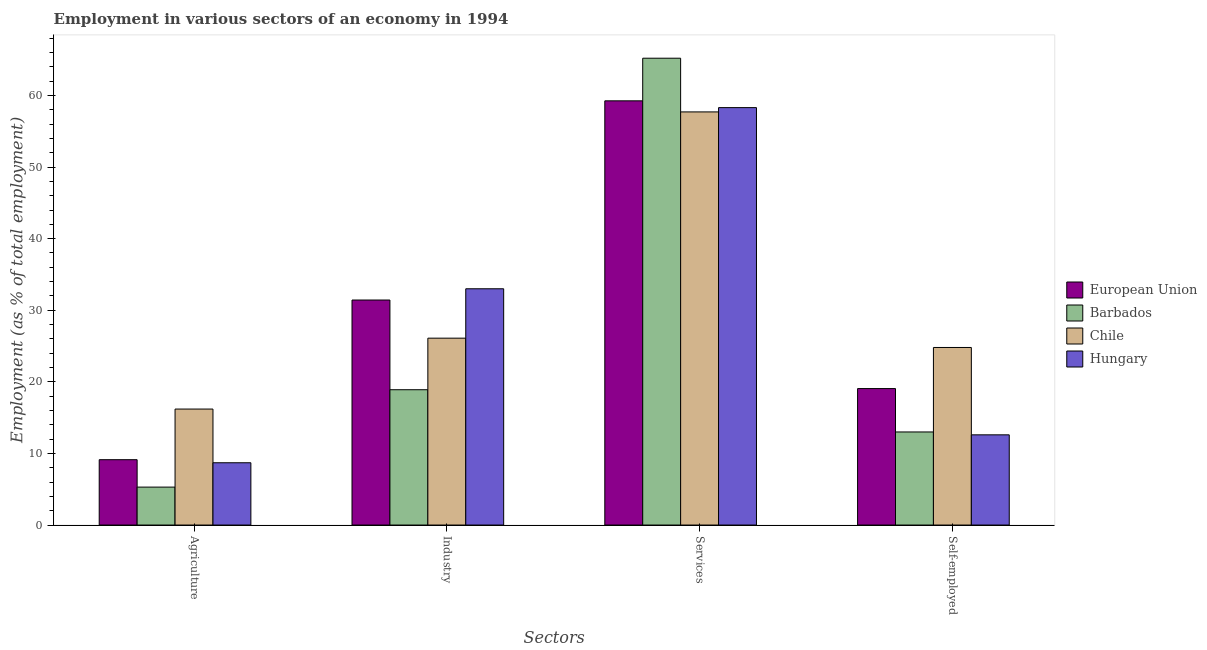How many different coloured bars are there?
Give a very brief answer. 4. How many bars are there on the 2nd tick from the left?
Keep it short and to the point. 4. How many bars are there on the 1st tick from the right?
Give a very brief answer. 4. What is the label of the 4th group of bars from the left?
Give a very brief answer. Self-employed. What is the percentage of workers in industry in Barbados?
Provide a short and direct response. 18.9. Across all countries, what is the maximum percentage of workers in industry?
Your answer should be compact. 33. Across all countries, what is the minimum percentage of workers in agriculture?
Provide a succinct answer. 5.3. In which country was the percentage of workers in agriculture maximum?
Your response must be concise. Chile. In which country was the percentage of workers in agriculture minimum?
Keep it short and to the point. Barbados. What is the total percentage of self employed workers in the graph?
Keep it short and to the point. 69.46. What is the difference between the percentage of self employed workers in Hungary and that in Chile?
Offer a very short reply. -12.2. What is the difference between the percentage of self employed workers in European Union and the percentage of workers in agriculture in Barbados?
Give a very brief answer. 13.76. What is the average percentage of workers in services per country?
Your response must be concise. 60.11. What is the difference between the percentage of workers in industry and percentage of workers in services in Hungary?
Your answer should be very brief. -25.3. In how many countries, is the percentage of workers in industry greater than 50 %?
Your answer should be very brief. 0. What is the ratio of the percentage of self employed workers in Hungary to that in Barbados?
Keep it short and to the point. 0.97. What is the difference between the highest and the second highest percentage of self employed workers?
Your response must be concise. 5.74. What is the difference between the highest and the lowest percentage of workers in agriculture?
Your answer should be compact. 10.9. Is it the case that in every country, the sum of the percentage of workers in agriculture and percentage of workers in services is greater than the sum of percentage of workers in industry and percentage of self employed workers?
Your answer should be very brief. No. What does the 2nd bar from the left in Agriculture represents?
Your answer should be compact. Barbados. Is it the case that in every country, the sum of the percentage of workers in agriculture and percentage of workers in industry is greater than the percentage of workers in services?
Keep it short and to the point. No. Does the graph contain grids?
Offer a very short reply. No. Where does the legend appear in the graph?
Ensure brevity in your answer.  Center right. How many legend labels are there?
Make the answer very short. 4. How are the legend labels stacked?
Provide a short and direct response. Vertical. What is the title of the graph?
Your response must be concise. Employment in various sectors of an economy in 1994. What is the label or title of the X-axis?
Provide a short and direct response. Sectors. What is the label or title of the Y-axis?
Give a very brief answer. Employment (as % of total employment). What is the Employment (as % of total employment) of European Union in Agriculture?
Your answer should be very brief. 9.13. What is the Employment (as % of total employment) of Barbados in Agriculture?
Give a very brief answer. 5.3. What is the Employment (as % of total employment) in Chile in Agriculture?
Provide a short and direct response. 16.2. What is the Employment (as % of total employment) in Hungary in Agriculture?
Offer a very short reply. 8.7. What is the Employment (as % of total employment) in European Union in Industry?
Give a very brief answer. 31.43. What is the Employment (as % of total employment) in Barbados in Industry?
Keep it short and to the point. 18.9. What is the Employment (as % of total employment) of Chile in Industry?
Make the answer very short. 26.1. What is the Employment (as % of total employment) in Hungary in Industry?
Ensure brevity in your answer.  33. What is the Employment (as % of total employment) in European Union in Services?
Your answer should be compact. 59.25. What is the Employment (as % of total employment) in Barbados in Services?
Your response must be concise. 65.2. What is the Employment (as % of total employment) of Chile in Services?
Your response must be concise. 57.7. What is the Employment (as % of total employment) in Hungary in Services?
Your answer should be compact. 58.3. What is the Employment (as % of total employment) of European Union in Self-employed?
Your response must be concise. 19.06. What is the Employment (as % of total employment) in Barbados in Self-employed?
Offer a terse response. 13. What is the Employment (as % of total employment) in Chile in Self-employed?
Give a very brief answer. 24.8. What is the Employment (as % of total employment) in Hungary in Self-employed?
Provide a succinct answer. 12.6. Across all Sectors, what is the maximum Employment (as % of total employment) in European Union?
Offer a terse response. 59.25. Across all Sectors, what is the maximum Employment (as % of total employment) of Barbados?
Make the answer very short. 65.2. Across all Sectors, what is the maximum Employment (as % of total employment) of Chile?
Your answer should be compact. 57.7. Across all Sectors, what is the maximum Employment (as % of total employment) in Hungary?
Keep it short and to the point. 58.3. Across all Sectors, what is the minimum Employment (as % of total employment) of European Union?
Your answer should be very brief. 9.13. Across all Sectors, what is the minimum Employment (as % of total employment) in Barbados?
Keep it short and to the point. 5.3. Across all Sectors, what is the minimum Employment (as % of total employment) of Chile?
Ensure brevity in your answer.  16.2. Across all Sectors, what is the minimum Employment (as % of total employment) of Hungary?
Provide a succinct answer. 8.7. What is the total Employment (as % of total employment) of European Union in the graph?
Make the answer very short. 118.86. What is the total Employment (as % of total employment) in Barbados in the graph?
Offer a very short reply. 102.4. What is the total Employment (as % of total employment) in Chile in the graph?
Ensure brevity in your answer.  124.8. What is the total Employment (as % of total employment) of Hungary in the graph?
Keep it short and to the point. 112.6. What is the difference between the Employment (as % of total employment) in European Union in Agriculture and that in Industry?
Offer a terse response. -22.3. What is the difference between the Employment (as % of total employment) of Barbados in Agriculture and that in Industry?
Your answer should be compact. -13.6. What is the difference between the Employment (as % of total employment) of Hungary in Agriculture and that in Industry?
Keep it short and to the point. -24.3. What is the difference between the Employment (as % of total employment) of European Union in Agriculture and that in Services?
Ensure brevity in your answer.  -50.12. What is the difference between the Employment (as % of total employment) in Barbados in Agriculture and that in Services?
Offer a very short reply. -59.9. What is the difference between the Employment (as % of total employment) in Chile in Agriculture and that in Services?
Provide a short and direct response. -41.5. What is the difference between the Employment (as % of total employment) of Hungary in Agriculture and that in Services?
Your response must be concise. -49.6. What is the difference between the Employment (as % of total employment) of European Union in Agriculture and that in Self-employed?
Offer a terse response. -9.93. What is the difference between the Employment (as % of total employment) in Chile in Agriculture and that in Self-employed?
Your answer should be compact. -8.6. What is the difference between the Employment (as % of total employment) in Hungary in Agriculture and that in Self-employed?
Offer a very short reply. -3.9. What is the difference between the Employment (as % of total employment) in European Union in Industry and that in Services?
Offer a terse response. -27.82. What is the difference between the Employment (as % of total employment) in Barbados in Industry and that in Services?
Provide a succinct answer. -46.3. What is the difference between the Employment (as % of total employment) of Chile in Industry and that in Services?
Keep it short and to the point. -31.6. What is the difference between the Employment (as % of total employment) in Hungary in Industry and that in Services?
Your response must be concise. -25.3. What is the difference between the Employment (as % of total employment) of European Union in Industry and that in Self-employed?
Give a very brief answer. 12.37. What is the difference between the Employment (as % of total employment) in Hungary in Industry and that in Self-employed?
Provide a short and direct response. 20.4. What is the difference between the Employment (as % of total employment) of European Union in Services and that in Self-employed?
Offer a very short reply. 40.19. What is the difference between the Employment (as % of total employment) in Barbados in Services and that in Self-employed?
Your answer should be compact. 52.2. What is the difference between the Employment (as % of total employment) in Chile in Services and that in Self-employed?
Give a very brief answer. 32.9. What is the difference between the Employment (as % of total employment) in Hungary in Services and that in Self-employed?
Make the answer very short. 45.7. What is the difference between the Employment (as % of total employment) in European Union in Agriculture and the Employment (as % of total employment) in Barbados in Industry?
Keep it short and to the point. -9.77. What is the difference between the Employment (as % of total employment) in European Union in Agriculture and the Employment (as % of total employment) in Chile in Industry?
Ensure brevity in your answer.  -16.97. What is the difference between the Employment (as % of total employment) in European Union in Agriculture and the Employment (as % of total employment) in Hungary in Industry?
Ensure brevity in your answer.  -23.87. What is the difference between the Employment (as % of total employment) of Barbados in Agriculture and the Employment (as % of total employment) of Chile in Industry?
Your answer should be compact. -20.8. What is the difference between the Employment (as % of total employment) of Barbados in Agriculture and the Employment (as % of total employment) of Hungary in Industry?
Give a very brief answer. -27.7. What is the difference between the Employment (as % of total employment) of Chile in Agriculture and the Employment (as % of total employment) of Hungary in Industry?
Ensure brevity in your answer.  -16.8. What is the difference between the Employment (as % of total employment) of European Union in Agriculture and the Employment (as % of total employment) of Barbados in Services?
Provide a short and direct response. -56.07. What is the difference between the Employment (as % of total employment) of European Union in Agriculture and the Employment (as % of total employment) of Chile in Services?
Offer a very short reply. -48.57. What is the difference between the Employment (as % of total employment) in European Union in Agriculture and the Employment (as % of total employment) in Hungary in Services?
Your answer should be compact. -49.17. What is the difference between the Employment (as % of total employment) in Barbados in Agriculture and the Employment (as % of total employment) in Chile in Services?
Your answer should be very brief. -52.4. What is the difference between the Employment (as % of total employment) in Barbados in Agriculture and the Employment (as % of total employment) in Hungary in Services?
Offer a terse response. -53. What is the difference between the Employment (as % of total employment) of Chile in Agriculture and the Employment (as % of total employment) of Hungary in Services?
Ensure brevity in your answer.  -42.1. What is the difference between the Employment (as % of total employment) of European Union in Agriculture and the Employment (as % of total employment) of Barbados in Self-employed?
Offer a terse response. -3.87. What is the difference between the Employment (as % of total employment) in European Union in Agriculture and the Employment (as % of total employment) in Chile in Self-employed?
Provide a succinct answer. -15.67. What is the difference between the Employment (as % of total employment) in European Union in Agriculture and the Employment (as % of total employment) in Hungary in Self-employed?
Your answer should be compact. -3.47. What is the difference between the Employment (as % of total employment) of Barbados in Agriculture and the Employment (as % of total employment) of Chile in Self-employed?
Your response must be concise. -19.5. What is the difference between the Employment (as % of total employment) in Barbados in Agriculture and the Employment (as % of total employment) in Hungary in Self-employed?
Ensure brevity in your answer.  -7.3. What is the difference between the Employment (as % of total employment) in European Union in Industry and the Employment (as % of total employment) in Barbados in Services?
Give a very brief answer. -33.77. What is the difference between the Employment (as % of total employment) in European Union in Industry and the Employment (as % of total employment) in Chile in Services?
Provide a succinct answer. -26.27. What is the difference between the Employment (as % of total employment) of European Union in Industry and the Employment (as % of total employment) of Hungary in Services?
Your answer should be very brief. -26.87. What is the difference between the Employment (as % of total employment) of Barbados in Industry and the Employment (as % of total employment) of Chile in Services?
Your answer should be compact. -38.8. What is the difference between the Employment (as % of total employment) in Barbados in Industry and the Employment (as % of total employment) in Hungary in Services?
Your answer should be compact. -39.4. What is the difference between the Employment (as % of total employment) in Chile in Industry and the Employment (as % of total employment) in Hungary in Services?
Give a very brief answer. -32.2. What is the difference between the Employment (as % of total employment) in European Union in Industry and the Employment (as % of total employment) in Barbados in Self-employed?
Give a very brief answer. 18.43. What is the difference between the Employment (as % of total employment) of European Union in Industry and the Employment (as % of total employment) of Chile in Self-employed?
Offer a very short reply. 6.63. What is the difference between the Employment (as % of total employment) in European Union in Industry and the Employment (as % of total employment) in Hungary in Self-employed?
Give a very brief answer. 18.83. What is the difference between the Employment (as % of total employment) in Barbados in Industry and the Employment (as % of total employment) in Chile in Self-employed?
Your response must be concise. -5.9. What is the difference between the Employment (as % of total employment) of European Union in Services and the Employment (as % of total employment) of Barbados in Self-employed?
Make the answer very short. 46.25. What is the difference between the Employment (as % of total employment) of European Union in Services and the Employment (as % of total employment) of Chile in Self-employed?
Offer a very short reply. 34.45. What is the difference between the Employment (as % of total employment) in European Union in Services and the Employment (as % of total employment) in Hungary in Self-employed?
Offer a very short reply. 46.65. What is the difference between the Employment (as % of total employment) in Barbados in Services and the Employment (as % of total employment) in Chile in Self-employed?
Offer a terse response. 40.4. What is the difference between the Employment (as % of total employment) in Barbados in Services and the Employment (as % of total employment) in Hungary in Self-employed?
Make the answer very short. 52.6. What is the difference between the Employment (as % of total employment) of Chile in Services and the Employment (as % of total employment) of Hungary in Self-employed?
Provide a short and direct response. 45.1. What is the average Employment (as % of total employment) of European Union per Sectors?
Your answer should be compact. 29.72. What is the average Employment (as % of total employment) in Barbados per Sectors?
Give a very brief answer. 25.6. What is the average Employment (as % of total employment) in Chile per Sectors?
Ensure brevity in your answer.  31.2. What is the average Employment (as % of total employment) of Hungary per Sectors?
Offer a terse response. 28.15. What is the difference between the Employment (as % of total employment) in European Union and Employment (as % of total employment) in Barbados in Agriculture?
Keep it short and to the point. 3.83. What is the difference between the Employment (as % of total employment) of European Union and Employment (as % of total employment) of Chile in Agriculture?
Provide a succinct answer. -7.07. What is the difference between the Employment (as % of total employment) of European Union and Employment (as % of total employment) of Hungary in Agriculture?
Provide a succinct answer. 0.43. What is the difference between the Employment (as % of total employment) of Barbados and Employment (as % of total employment) of Chile in Agriculture?
Offer a terse response. -10.9. What is the difference between the Employment (as % of total employment) in Barbados and Employment (as % of total employment) in Hungary in Agriculture?
Make the answer very short. -3.4. What is the difference between the Employment (as % of total employment) of European Union and Employment (as % of total employment) of Barbados in Industry?
Give a very brief answer. 12.53. What is the difference between the Employment (as % of total employment) in European Union and Employment (as % of total employment) in Chile in Industry?
Provide a short and direct response. 5.33. What is the difference between the Employment (as % of total employment) of European Union and Employment (as % of total employment) of Hungary in Industry?
Give a very brief answer. -1.57. What is the difference between the Employment (as % of total employment) of Barbados and Employment (as % of total employment) of Chile in Industry?
Your answer should be very brief. -7.2. What is the difference between the Employment (as % of total employment) in Barbados and Employment (as % of total employment) in Hungary in Industry?
Keep it short and to the point. -14.1. What is the difference between the Employment (as % of total employment) in European Union and Employment (as % of total employment) in Barbados in Services?
Your answer should be very brief. -5.95. What is the difference between the Employment (as % of total employment) in European Union and Employment (as % of total employment) in Chile in Services?
Offer a very short reply. 1.55. What is the difference between the Employment (as % of total employment) of European Union and Employment (as % of total employment) of Hungary in Services?
Keep it short and to the point. 0.95. What is the difference between the Employment (as % of total employment) in Barbados and Employment (as % of total employment) in Hungary in Services?
Keep it short and to the point. 6.9. What is the difference between the Employment (as % of total employment) in Chile and Employment (as % of total employment) in Hungary in Services?
Offer a very short reply. -0.6. What is the difference between the Employment (as % of total employment) of European Union and Employment (as % of total employment) of Barbados in Self-employed?
Provide a succinct answer. 6.06. What is the difference between the Employment (as % of total employment) of European Union and Employment (as % of total employment) of Chile in Self-employed?
Provide a succinct answer. -5.74. What is the difference between the Employment (as % of total employment) in European Union and Employment (as % of total employment) in Hungary in Self-employed?
Your answer should be compact. 6.46. What is the difference between the Employment (as % of total employment) of Chile and Employment (as % of total employment) of Hungary in Self-employed?
Your response must be concise. 12.2. What is the ratio of the Employment (as % of total employment) in European Union in Agriculture to that in Industry?
Keep it short and to the point. 0.29. What is the ratio of the Employment (as % of total employment) of Barbados in Agriculture to that in Industry?
Your response must be concise. 0.28. What is the ratio of the Employment (as % of total employment) in Chile in Agriculture to that in Industry?
Your response must be concise. 0.62. What is the ratio of the Employment (as % of total employment) of Hungary in Agriculture to that in Industry?
Your answer should be compact. 0.26. What is the ratio of the Employment (as % of total employment) in European Union in Agriculture to that in Services?
Offer a very short reply. 0.15. What is the ratio of the Employment (as % of total employment) of Barbados in Agriculture to that in Services?
Offer a very short reply. 0.08. What is the ratio of the Employment (as % of total employment) of Chile in Agriculture to that in Services?
Your answer should be compact. 0.28. What is the ratio of the Employment (as % of total employment) in Hungary in Agriculture to that in Services?
Your answer should be very brief. 0.15. What is the ratio of the Employment (as % of total employment) in European Union in Agriculture to that in Self-employed?
Make the answer very short. 0.48. What is the ratio of the Employment (as % of total employment) of Barbados in Agriculture to that in Self-employed?
Your answer should be compact. 0.41. What is the ratio of the Employment (as % of total employment) in Chile in Agriculture to that in Self-employed?
Provide a short and direct response. 0.65. What is the ratio of the Employment (as % of total employment) of Hungary in Agriculture to that in Self-employed?
Your answer should be very brief. 0.69. What is the ratio of the Employment (as % of total employment) in European Union in Industry to that in Services?
Make the answer very short. 0.53. What is the ratio of the Employment (as % of total employment) in Barbados in Industry to that in Services?
Offer a terse response. 0.29. What is the ratio of the Employment (as % of total employment) of Chile in Industry to that in Services?
Make the answer very short. 0.45. What is the ratio of the Employment (as % of total employment) of Hungary in Industry to that in Services?
Provide a short and direct response. 0.57. What is the ratio of the Employment (as % of total employment) in European Union in Industry to that in Self-employed?
Keep it short and to the point. 1.65. What is the ratio of the Employment (as % of total employment) of Barbados in Industry to that in Self-employed?
Give a very brief answer. 1.45. What is the ratio of the Employment (as % of total employment) in Chile in Industry to that in Self-employed?
Your response must be concise. 1.05. What is the ratio of the Employment (as % of total employment) in Hungary in Industry to that in Self-employed?
Make the answer very short. 2.62. What is the ratio of the Employment (as % of total employment) of European Union in Services to that in Self-employed?
Your answer should be very brief. 3.11. What is the ratio of the Employment (as % of total employment) in Barbados in Services to that in Self-employed?
Provide a succinct answer. 5.02. What is the ratio of the Employment (as % of total employment) in Chile in Services to that in Self-employed?
Keep it short and to the point. 2.33. What is the ratio of the Employment (as % of total employment) in Hungary in Services to that in Self-employed?
Keep it short and to the point. 4.63. What is the difference between the highest and the second highest Employment (as % of total employment) of European Union?
Make the answer very short. 27.82. What is the difference between the highest and the second highest Employment (as % of total employment) of Barbados?
Offer a terse response. 46.3. What is the difference between the highest and the second highest Employment (as % of total employment) in Chile?
Provide a short and direct response. 31.6. What is the difference between the highest and the second highest Employment (as % of total employment) in Hungary?
Your answer should be compact. 25.3. What is the difference between the highest and the lowest Employment (as % of total employment) in European Union?
Your response must be concise. 50.12. What is the difference between the highest and the lowest Employment (as % of total employment) of Barbados?
Your response must be concise. 59.9. What is the difference between the highest and the lowest Employment (as % of total employment) in Chile?
Provide a succinct answer. 41.5. What is the difference between the highest and the lowest Employment (as % of total employment) in Hungary?
Keep it short and to the point. 49.6. 